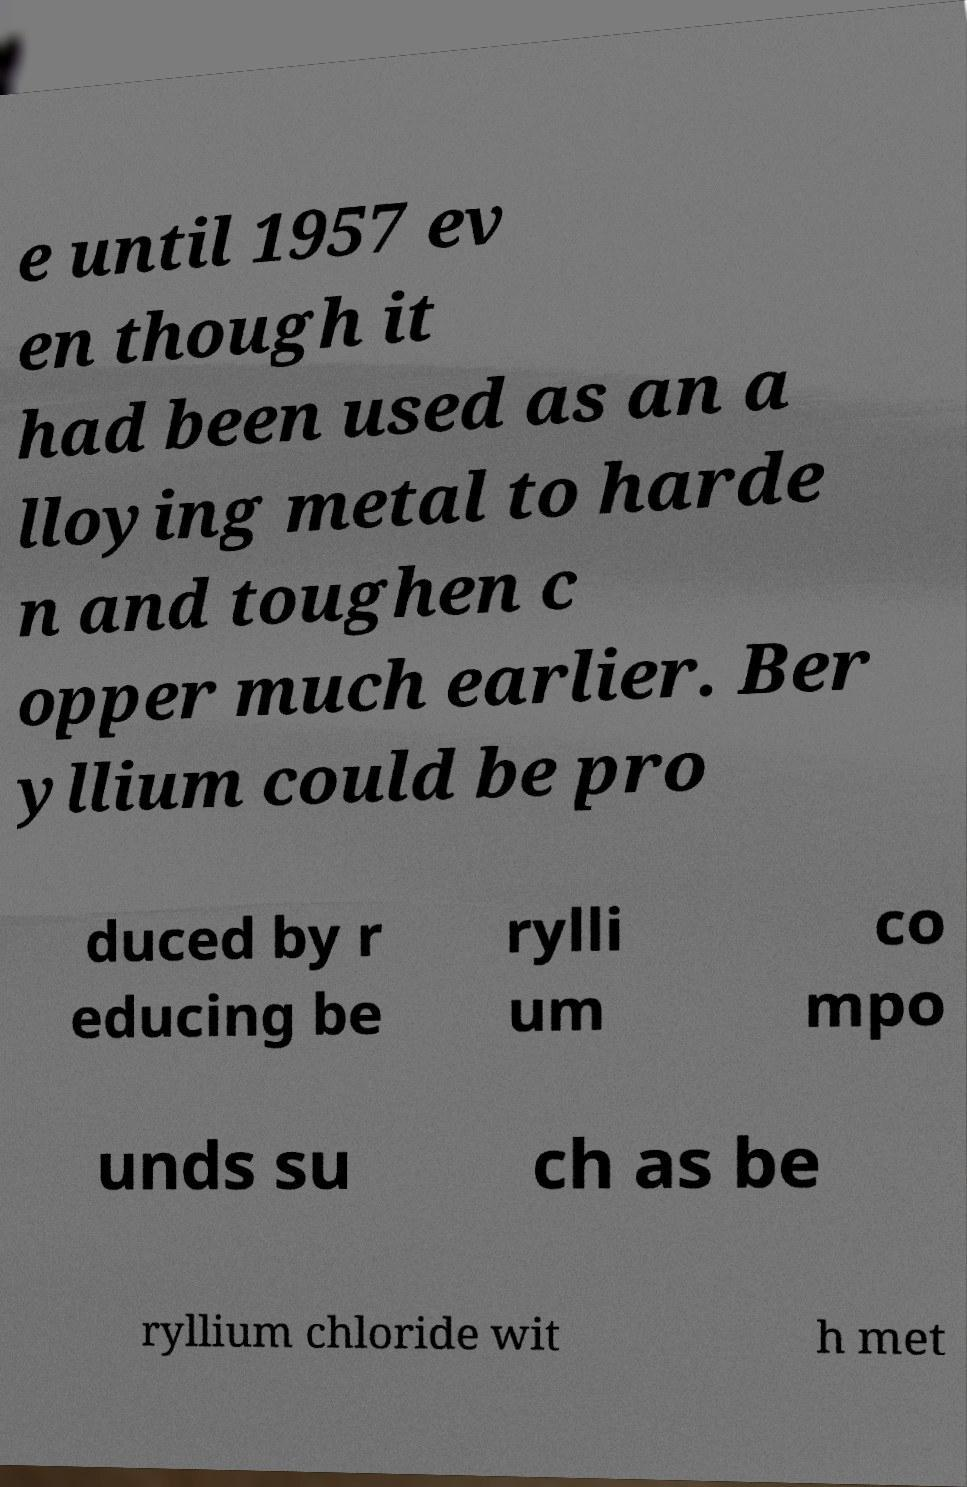What messages or text are displayed in this image? I need them in a readable, typed format. e until 1957 ev en though it had been used as an a lloying metal to harde n and toughen c opper much earlier. Ber yllium could be pro duced by r educing be rylli um co mpo unds su ch as be ryllium chloride wit h met 